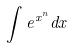Convert formula to latex. <formula><loc_0><loc_0><loc_500><loc_500>\int e ^ { x ^ { n } } d x</formula> 